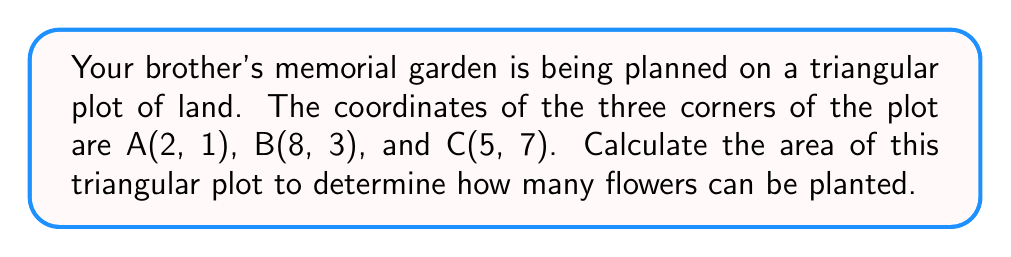Give your solution to this math problem. To calculate the area of a triangle using coordinate geometry, we can use the formula:

$$\text{Area} = \frac{1}{2}|x_1(y_2 - y_3) + x_2(y_3 - y_1) + x_3(y_1 - y_2)|$$

Where $(x_1, y_1)$, $(x_2, y_2)$, and $(x_3, y_3)$ are the coordinates of the three vertices of the triangle.

Let's substitute the given coordinates:
A(2, 1), B(8, 3), C(5, 7)

So, $x_1 = 2$, $y_1 = 1$, $x_2 = 8$, $y_2 = 3$, $x_3 = 5$, $y_3 = 7$

Now, let's plug these values into the formula:

$$\begin{align*}
\text{Area} &= \frac{1}{2}|2(3 - 7) + 8(7 - 1) + 5(1 - 3)|\\
&= \frac{1}{2}|2(-4) + 8(6) + 5(-2)|\\
&= \frac{1}{2}|-8 + 48 - 10|\\
&= \frac{1}{2}|30|\\
&= \frac{1}{2}(30)\\
&= 15
\end{align*}$$

The area of the triangular plot is 15 square units.

[asy]
unitsize(1cm);
pair A = (2,1);
pair B = (8,3);
pair C = (5,7);
draw(A--B--C--cycle);
label("A(2,1)", A, SW);
label("B(8,3)", B, SE);
label("C(5,7)", C, N);
dot(A);
dot(B);
dot(C);
[/asy]
Answer: The area of the triangular plot is 15 square units. 